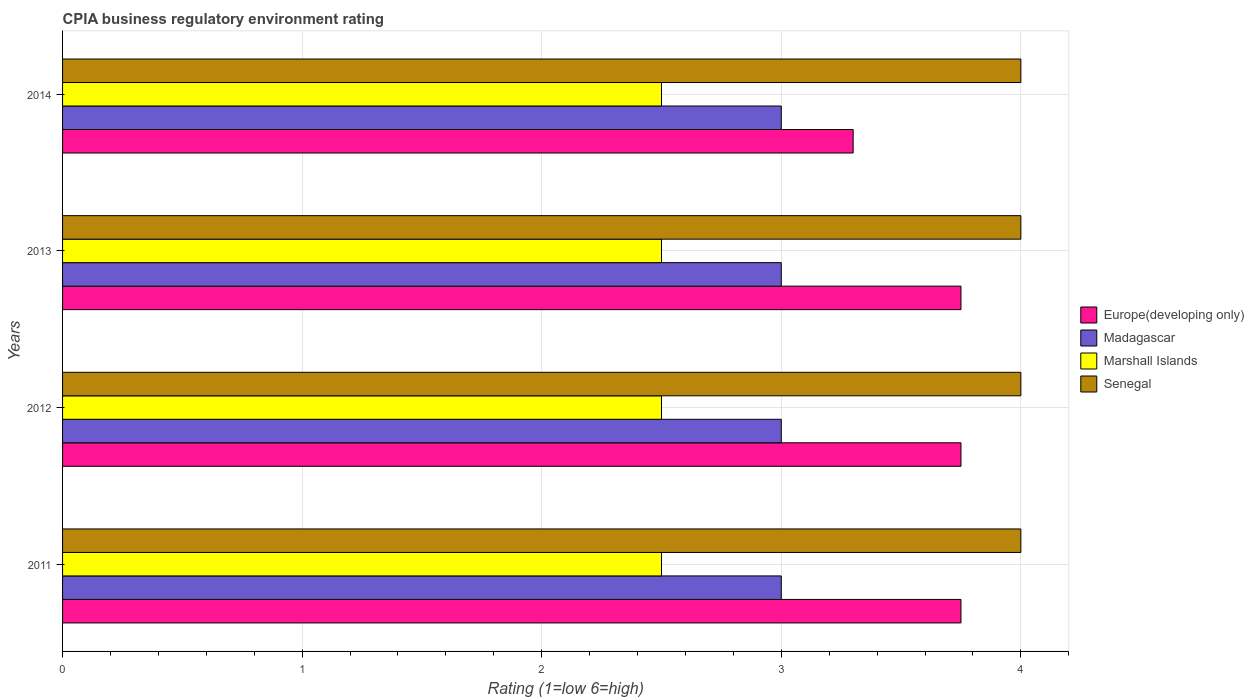How many different coloured bars are there?
Provide a succinct answer. 4. How many groups of bars are there?
Provide a succinct answer. 4. How many bars are there on the 3rd tick from the top?
Keep it short and to the point. 4. What is the label of the 4th group of bars from the top?
Your answer should be very brief. 2011. In how many cases, is the number of bars for a given year not equal to the number of legend labels?
Offer a terse response. 0. What is the CPIA rating in Europe(developing only) in 2012?
Ensure brevity in your answer.  3.75. Across all years, what is the maximum CPIA rating in Senegal?
Keep it short and to the point. 4. Across all years, what is the minimum CPIA rating in Europe(developing only)?
Your answer should be very brief. 3.3. In which year was the CPIA rating in Madagascar maximum?
Give a very brief answer. 2011. In which year was the CPIA rating in Marshall Islands minimum?
Keep it short and to the point. 2011. What is the total CPIA rating in Marshall Islands in the graph?
Offer a very short reply. 10. What is the difference between the CPIA rating in Marshall Islands in 2011 and the CPIA rating in Europe(developing only) in 2013?
Your answer should be very brief. -1.25. What is the average CPIA rating in Europe(developing only) per year?
Your response must be concise. 3.64. Is the difference between the CPIA rating in Senegal in 2011 and 2013 greater than the difference between the CPIA rating in Marshall Islands in 2011 and 2013?
Keep it short and to the point. No. What is the difference between the highest and the lowest CPIA rating in Senegal?
Provide a short and direct response. 0. In how many years, is the CPIA rating in Madagascar greater than the average CPIA rating in Madagascar taken over all years?
Offer a very short reply. 0. What does the 2nd bar from the top in 2014 represents?
Offer a very short reply. Marshall Islands. What does the 3rd bar from the bottom in 2011 represents?
Your answer should be compact. Marshall Islands. Is it the case that in every year, the sum of the CPIA rating in Senegal and CPIA rating in Europe(developing only) is greater than the CPIA rating in Marshall Islands?
Provide a short and direct response. Yes. Are all the bars in the graph horizontal?
Provide a succinct answer. Yes. How many years are there in the graph?
Offer a terse response. 4. Does the graph contain any zero values?
Your answer should be very brief. No. Does the graph contain grids?
Keep it short and to the point. Yes. How many legend labels are there?
Offer a very short reply. 4. What is the title of the graph?
Offer a very short reply. CPIA business regulatory environment rating. Does "Cyprus" appear as one of the legend labels in the graph?
Your answer should be very brief. No. What is the label or title of the X-axis?
Your answer should be very brief. Rating (1=low 6=high). What is the Rating (1=low 6=high) in Europe(developing only) in 2011?
Provide a short and direct response. 3.75. What is the Rating (1=low 6=high) of Madagascar in 2011?
Provide a short and direct response. 3. What is the Rating (1=low 6=high) in Marshall Islands in 2011?
Provide a short and direct response. 2.5. What is the Rating (1=low 6=high) of Senegal in 2011?
Keep it short and to the point. 4. What is the Rating (1=low 6=high) in Europe(developing only) in 2012?
Provide a succinct answer. 3.75. What is the Rating (1=low 6=high) in Madagascar in 2012?
Your response must be concise. 3. What is the Rating (1=low 6=high) of Europe(developing only) in 2013?
Provide a succinct answer. 3.75. What is the Rating (1=low 6=high) in Marshall Islands in 2013?
Ensure brevity in your answer.  2.5. What is the Rating (1=low 6=high) in Madagascar in 2014?
Offer a very short reply. 3. What is the Rating (1=low 6=high) in Senegal in 2014?
Make the answer very short. 4. Across all years, what is the maximum Rating (1=low 6=high) in Europe(developing only)?
Provide a short and direct response. 3.75. Across all years, what is the maximum Rating (1=low 6=high) in Senegal?
Provide a succinct answer. 4. Across all years, what is the minimum Rating (1=low 6=high) of Marshall Islands?
Provide a succinct answer. 2.5. Across all years, what is the minimum Rating (1=low 6=high) of Senegal?
Offer a terse response. 4. What is the total Rating (1=low 6=high) in Europe(developing only) in the graph?
Your answer should be compact. 14.55. What is the total Rating (1=low 6=high) in Madagascar in the graph?
Your response must be concise. 12. What is the total Rating (1=low 6=high) in Marshall Islands in the graph?
Offer a very short reply. 10. What is the difference between the Rating (1=low 6=high) in Europe(developing only) in 2011 and that in 2012?
Make the answer very short. 0. What is the difference between the Rating (1=low 6=high) in Madagascar in 2011 and that in 2012?
Provide a succinct answer. 0. What is the difference between the Rating (1=low 6=high) of Madagascar in 2011 and that in 2013?
Your response must be concise. 0. What is the difference between the Rating (1=low 6=high) in Senegal in 2011 and that in 2013?
Your response must be concise. 0. What is the difference between the Rating (1=low 6=high) in Europe(developing only) in 2011 and that in 2014?
Make the answer very short. 0.45. What is the difference between the Rating (1=low 6=high) of Europe(developing only) in 2012 and that in 2013?
Offer a very short reply. 0. What is the difference between the Rating (1=low 6=high) of Senegal in 2012 and that in 2013?
Provide a short and direct response. 0. What is the difference between the Rating (1=low 6=high) of Europe(developing only) in 2012 and that in 2014?
Provide a short and direct response. 0.45. What is the difference between the Rating (1=low 6=high) in Madagascar in 2012 and that in 2014?
Provide a short and direct response. 0. What is the difference between the Rating (1=low 6=high) of Europe(developing only) in 2013 and that in 2014?
Your answer should be compact. 0.45. What is the difference between the Rating (1=low 6=high) of Europe(developing only) in 2011 and the Rating (1=low 6=high) of Madagascar in 2012?
Keep it short and to the point. 0.75. What is the difference between the Rating (1=low 6=high) of Europe(developing only) in 2011 and the Rating (1=low 6=high) of Marshall Islands in 2012?
Give a very brief answer. 1.25. What is the difference between the Rating (1=low 6=high) in Europe(developing only) in 2011 and the Rating (1=low 6=high) in Madagascar in 2013?
Your answer should be very brief. 0.75. What is the difference between the Rating (1=low 6=high) of Madagascar in 2011 and the Rating (1=low 6=high) of Senegal in 2013?
Your answer should be very brief. -1. What is the difference between the Rating (1=low 6=high) in Marshall Islands in 2011 and the Rating (1=low 6=high) in Senegal in 2013?
Your answer should be very brief. -1.5. What is the difference between the Rating (1=low 6=high) of Europe(developing only) in 2011 and the Rating (1=low 6=high) of Madagascar in 2014?
Offer a very short reply. 0.75. What is the difference between the Rating (1=low 6=high) in Europe(developing only) in 2011 and the Rating (1=low 6=high) in Senegal in 2014?
Provide a succinct answer. -0.25. What is the difference between the Rating (1=low 6=high) in Madagascar in 2011 and the Rating (1=low 6=high) in Senegal in 2014?
Provide a short and direct response. -1. What is the difference between the Rating (1=low 6=high) of Marshall Islands in 2011 and the Rating (1=low 6=high) of Senegal in 2014?
Your answer should be compact. -1.5. What is the difference between the Rating (1=low 6=high) of Europe(developing only) in 2012 and the Rating (1=low 6=high) of Madagascar in 2013?
Provide a succinct answer. 0.75. What is the difference between the Rating (1=low 6=high) in Europe(developing only) in 2012 and the Rating (1=low 6=high) in Marshall Islands in 2013?
Your answer should be very brief. 1.25. What is the difference between the Rating (1=low 6=high) in Europe(developing only) in 2012 and the Rating (1=low 6=high) in Senegal in 2013?
Provide a short and direct response. -0.25. What is the difference between the Rating (1=low 6=high) of Madagascar in 2012 and the Rating (1=low 6=high) of Marshall Islands in 2013?
Your answer should be very brief. 0.5. What is the difference between the Rating (1=low 6=high) in Madagascar in 2012 and the Rating (1=low 6=high) in Senegal in 2013?
Offer a terse response. -1. What is the difference between the Rating (1=low 6=high) in Europe(developing only) in 2012 and the Rating (1=low 6=high) in Madagascar in 2014?
Provide a succinct answer. 0.75. What is the difference between the Rating (1=low 6=high) in Europe(developing only) in 2012 and the Rating (1=low 6=high) in Marshall Islands in 2014?
Make the answer very short. 1.25. What is the difference between the Rating (1=low 6=high) in Europe(developing only) in 2012 and the Rating (1=low 6=high) in Senegal in 2014?
Offer a very short reply. -0.25. What is the difference between the Rating (1=low 6=high) of Madagascar in 2012 and the Rating (1=low 6=high) of Marshall Islands in 2014?
Ensure brevity in your answer.  0.5. What is the difference between the Rating (1=low 6=high) of Madagascar in 2012 and the Rating (1=low 6=high) of Senegal in 2014?
Keep it short and to the point. -1. What is the difference between the Rating (1=low 6=high) of Marshall Islands in 2012 and the Rating (1=low 6=high) of Senegal in 2014?
Your answer should be compact. -1.5. What is the difference between the Rating (1=low 6=high) in Europe(developing only) in 2013 and the Rating (1=low 6=high) in Senegal in 2014?
Your response must be concise. -0.25. What is the difference between the Rating (1=low 6=high) in Madagascar in 2013 and the Rating (1=low 6=high) in Marshall Islands in 2014?
Give a very brief answer. 0.5. What is the average Rating (1=low 6=high) of Europe(developing only) per year?
Offer a terse response. 3.64. What is the average Rating (1=low 6=high) in Madagascar per year?
Ensure brevity in your answer.  3. What is the average Rating (1=low 6=high) of Marshall Islands per year?
Make the answer very short. 2.5. What is the average Rating (1=low 6=high) of Senegal per year?
Provide a succinct answer. 4. In the year 2011, what is the difference between the Rating (1=low 6=high) of Europe(developing only) and Rating (1=low 6=high) of Madagascar?
Your answer should be very brief. 0.75. In the year 2011, what is the difference between the Rating (1=low 6=high) of Europe(developing only) and Rating (1=low 6=high) of Senegal?
Ensure brevity in your answer.  -0.25. In the year 2011, what is the difference between the Rating (1=low 6=high) of Madagascar and Rating (1=low 6=high) of Marshall Islands?
Your response must be concise. 0.5. In the year 2011, what is the difference between the Rating (1=low 6=high) in Madagascar and Rating (1=low 6=high) in Senegal?
Provide a succinct answer. -1. In the year 2012, what is the difference between the Rating (1=low 6=high) in Europe(developing only) and Rating (1=low 6=high) in Madagascar?
Make the answer very short. 0.75. In the year 2012, what is the difference between the Rating (1=low 6=high) of Europe(developing only) and Rating (1=low 6=high) of Marshall Islands?
Give a very brief answer. 1.25. In the year 2012, what is the difference between the Rating (1=low 6=high) in Europe(developing only) and Rating (1=low 6=high) in Senegal?
Ensure brevity in your answer.  -0.25. In the year 2013, what is the difference between the Rating (1=low 6=high) of Europe(developing only) and Rating (1=low 6=high) of Marshall Islands?
Provide a short and direct response. 1.25. In the year 2013, what is the difference between the Rating (1=low 6=high) in Madagascar and Rating (1=low 6=high) in Marshall Islands?
Offer a terse response. 0.5. In the year 2013, what is the difference between the Rating (1=low 6=high) of Madagascar and Rating (1=low 6=high) of Senegal?
Your answer should be very brief. -1. In the year 2013, what is the difference between the Rating (1=low 6=high) of Marshall Islands and Rating (1=low 6=high) of Senegal?
Your answer should be compact. -1.5. In the year 2014, what is the difference between the Rating (1=low 6=high) in Europe(developing only) and Rating (1=low 6=high) in Madagascar?
Give a very brief answer. 0.3. In the year 2014, what is the difference between the Rating (1=low 6=high) of Europe(developing only) and Rating (1=low 6=high) of Senegal?
Give a very brief answer. -0.7. In the year 2014, what is the difference between the Rating (1=low 6=high) in Madagascar and Rating (1=low 6=high) in Senegal?
Provide a succinct answer. -1. What is the ratio of the Rating (1=low 6=high) in Madagascar in 2011 to that in 2012?
Your answer should be compact. 1. What is the ratio of the Rating (1=low 6=high) in Europe(developing only) in 2011 to that in 2014?
Ensure brevity in your answer.  1.14. What is the ratio of the Rating (1=low 6=high) of Europe(developing only) in 2012 to that in 2013?
Provide a succinct answer. 1. What is the ratio of the Rating (1=low 6=high) of Madagascar in 2012 to that in 2013?
Offer a very short reply. 1. What is the ratio of the Rating (1=low 6=high) of Europe(developing only) in 2012 to that in 2014?
Provide a succinct answer. 1.14. What is the ratio of the Rating (1=low 6=high) of Marshall Islands in 2012 to that in 2014?
Offer a terse response. 1. What is the ratio of the Rating (1=low 6=high) of Senegal in 2012 to that in 2014?
Make the answer very short. 1. What is the ratio of the Rating (1=low 6=high) of Europe(developing only) in 2013 to that in 2014?
Make the answer very short. 1.14. What is the ratio of the Rating (1=low 6=high) in Marshall Islands in 2013 to that in 2014?
Your answer should be very brief. 1. What is the ratio of the Rating (1=low 6=high) in Senegal in 2013 to that in 2014?
Your answer should be compact. 1. What is the difference between the highest and the second highest Rating (1=low 6=high) in Marshall Islands?
Give a very brief answer. 0. What is the difference between the highest and the lowest Rating (1=low 6=high) of Europe(developing only)?
Ensure brevity in your answer.  0.45. What is the difference between the highest and the lowest Rating (1=low 6=high) of Madagascar?
Your response must be concise. 0. What is the difference between the highest and the lowest Rating (1=low 6=high) of Marshall Islands?
Offer a very short reply. 0. 